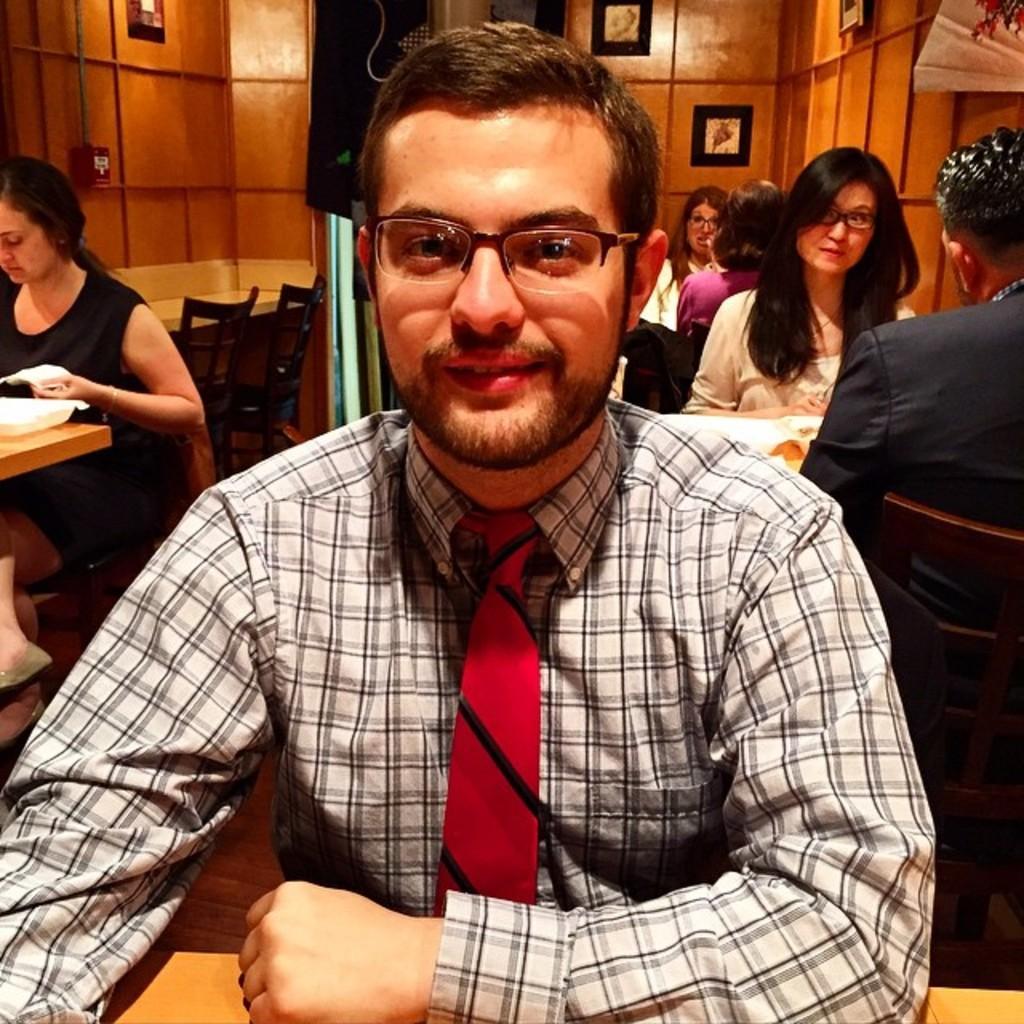How would you summarize this image in a sentence or two? In this picture we can see there are groups of people sitting on chairs. In front of the people there are tables. On the left side of the image there is a white object on the table. Behind the people there is a black object and there are photo frames and an object on the wall. 